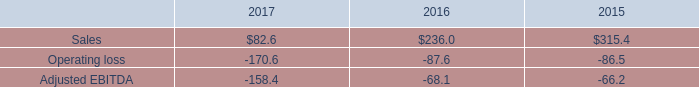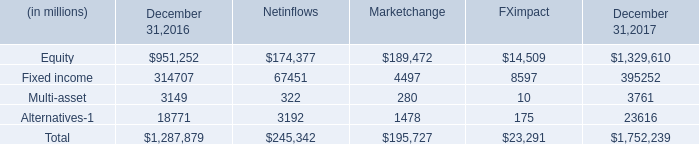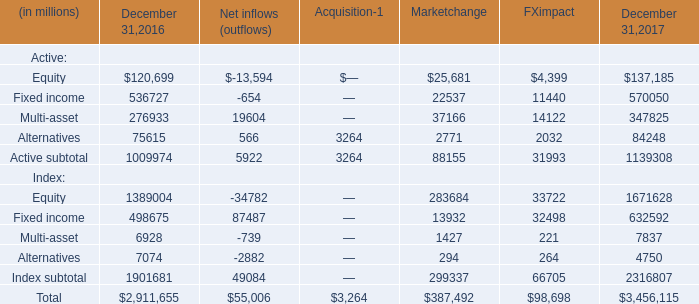What's the average of Equity in 2016 and 2017? (in millions) 
Computations: ((120699 + 137185) / 2)
Answer: 128942.0. 